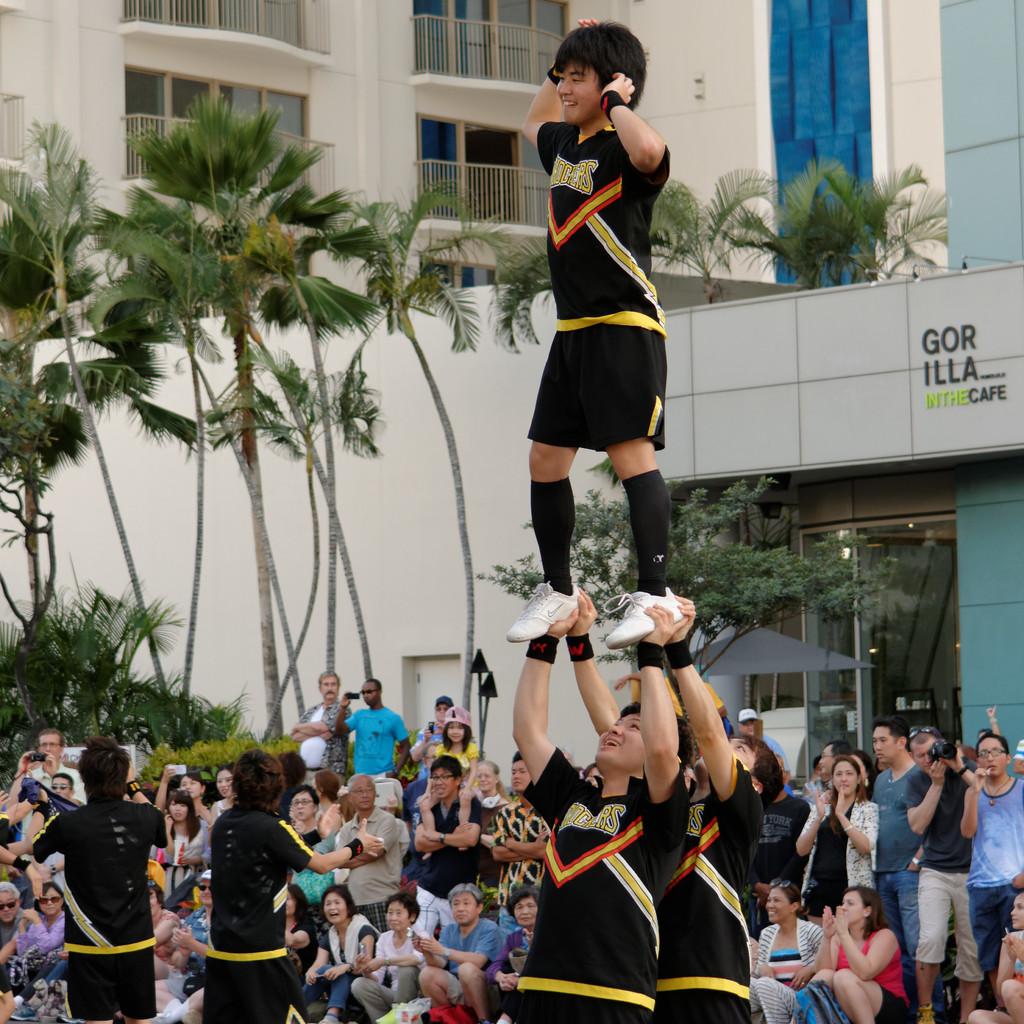What letters are visible on the black jerseys?
Keep it short and to the point. Shockers. 